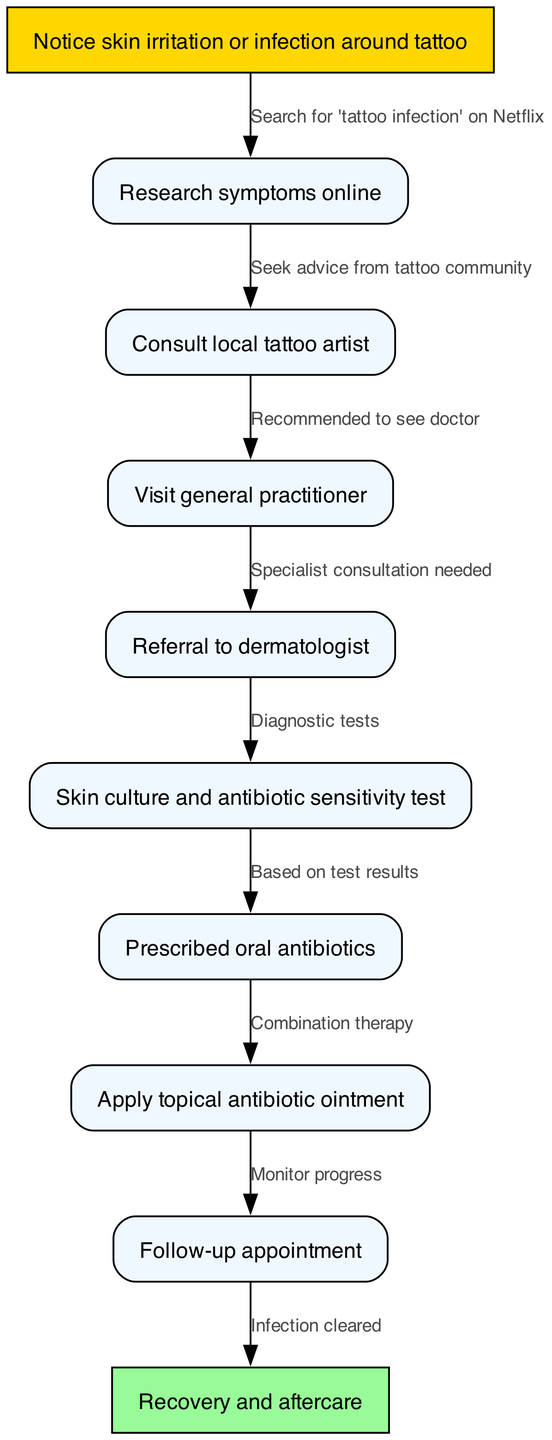What is the first step in the patient journey? The first step in the journey is to notice skin irritation or infection around the tattoo, as indicated by node 1.
Answer: Notice skin irritation or infection around tattoo How many nodes are present in the diagram? The diagram shows a total of 10 nodes representing different stages in the clinical pathway.
Answer: 10 Which node follows the 'Visit general practitioner' step? The node that follows 'Visit general practitioner' (node 4) is 'Referral to dermatologist' (node 5), indicating the next step after visiting the GP.
Answer: Referral to dermatologist What type of test is performed after the referral to the dermatologist? A 'Skin culture and antibiotic sensitivity test' is performed after the referral, according to the connection from node 5 to node 6.
Answer: Skin culture and antibiotic sensitivity test What therapy is prescribed after the skin culture results? After the skin culture results, the patient is prescribed oral antibiotics, as shown in the transition from node 6 to node 7.
Answer: Prescribed oral antibiotics In what way is therapy administered after the oral antibiotics? After being prescribed oral antibiotics, the patient also applies a topical antibiotic ointment, reflecting a combination therapy as indicated between nodes 7 and 8.
Answer: Apply topical antibiotic ointment What does the follow-up appointment aim to monitor? The follow-up appointment aims to monitor the progress of the infection, as indicated by the flow from node 8 to node 9.
Answer: Monitor progress How does the diagram indicate successful treatment completion? Successful treatment completion is indicated by the final node, which states 'Infection cleared', following the follow-up appointment.
Answer: Infection cleared What is the connection between 'Research symptoms online' and 'Consult local tattoo artist'? The connection indicates that individuals who research symptoms online might seek advice from the tattoo community, as seen in the edge between node 2 and node 3.
Answer: Seek advice from tattoo community 